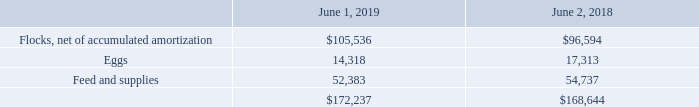4. Inventories
Inventories consisted of the following (in thousands):
We grow and maintain flocks of layers (mature female chickens), pullets (female chickens, under 18 weeks of age), and breeders (male and female chickens used to produce fertile eggs to hatch for egg production flocks). Our total flock at June 1, 2019, consisted of approximately 9.4 million pullets and breeders and 36.2 million layers.
What is the number of eggs in 2019?
Answer scale should be: thousand. 14,318. What is the increase / (decrease) in number of eggs in 2019?
Answer scale should be: thousand. 14,318 - 17,313
Answer: -2995. What was the flock composition in June 2019? Consisted of approximately 9.4 million pullets and breeders and 36.2 million layers. What is the age for the pullets? Under 18 weeks. What is the percentage increase / (decrease) in feed and supplies in 2019 compared to 2018?
Answer scale should be: percent. 52,383 / 54,737 - 1
Answer: -4.3. What is the increase / (decrease) in total inventory in 2019 compared to 2018?
Answer scale should be: thousand. 172,237 - 168,644
Answer: 3593. 